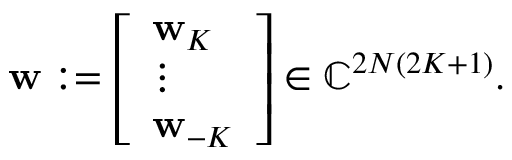<formula> <loc_0><loc_0><loc_500><loc_500>\begin{array} { r } { w \colon = \left [ \begin{array} { l } { w _ { K } } \\ { \vdots } \\ { w _ { - K } } \end{array} \right ] \in \mathbb { C } ^ { 2 N ( 2 K + 1 ) } . } \end{array}</formula> 